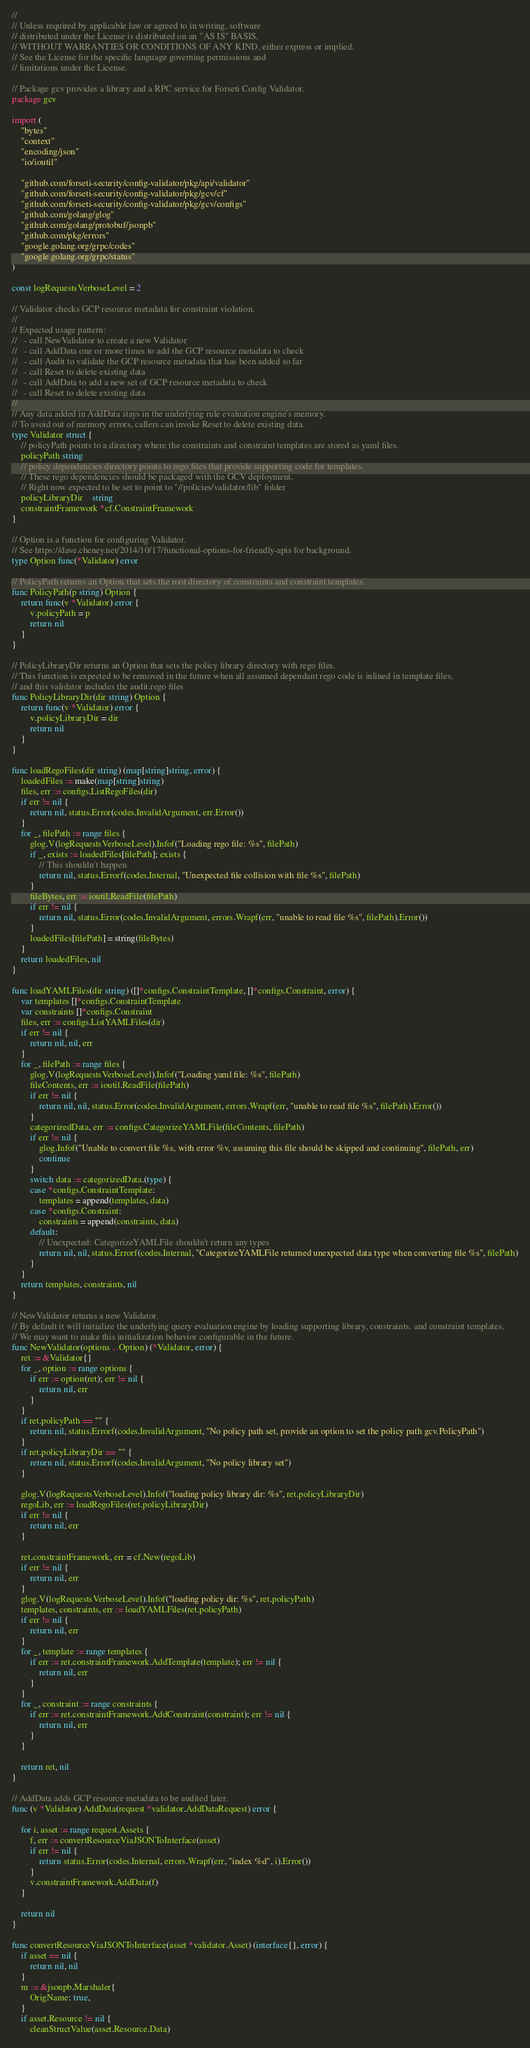<code> <loc_0><loc_0><loc_500><loc_500><_Go_>//
// Unless required by applicable law or agreed to in writing, software
// distributed under the License is distributed on an "AS IS" BASIS,
// WITHOUT WARRANTIES OR CONDITIONS OF ANY KIND, either express or implied.
// See the License for the specific language governing permissions and
// limitations under the License.

// Package gcv provides a library and a RPC service for Forseti Config Validator.
package gcv

import (
	"bytes"
	"context"
	"encoding/json"
	"io/ioutil"

	"github.com/forseti-security/config-validator/pkg/api/validator"
	"github.com/forseti-security/config-validator/pkg/gcv/cf"
	"github.com/forseti-security/config-validator/pkg/gcv/configs"
	"github.com/golang/glog"
	"github.com/golang/protobuf/jsonpb"
	"github.com/pkg/errors"
	"google.golang.org/grpc/codes"
	"google.golang.org/grpc/status"
)

const logRequestsVerboseLevel = 2

// Validator checks GCP resource metadata for constraint violation.
//
// Expected usage pattern:
//   - call NewValidator to create a new Validator
//   - call AddData one or more times to add the GCP resource metadata to check
//   - call Audit to validate the GCP resource metadata that has been added so far
//   - call Reset to delete existing data
//   - call AddData to add a new set of GCP resource metadata to check
//   - call Reset to delete existing data
//
// Any data added in AddData stays in the underlying rule evaluation engine's memory.
// To avoid out of memory errors, callers can invoke Reset to delete existing data.
type Validator struct {
	// policyPath points to a directory where the constraints and constraint templates are stored as yaml files.
	policyPath string
	// policy dependencies directory points to rego files that provide supporting code for templates.
	// These rego dependencies should be packaged with the GCV deployment.
	// Right now expected to be set to point to "//policies/validator/lib" folder
	policyLibraryDir    string
	constraintFramework *cf.ConstraintFramework
}

// Option is a function for configuring Validator.
// See https://dave.cheney.net/2014/10/17/functional-options-for-friendly-apis for background.
type Option func(*Validator) error

// PolicyPath returns an Option that sets the root directory of constraints and constraint templates.
func PolicyPath(p string) Option {
	return func(v *Validator) error {
		v.policyPath = p
		return nil
	}
}

// PolicyLibraryDir returns an Option that sets the policy library directory with rego files.
// This function is expected to be removed in the future when all assumed dependant rego code is inlined in template files,
// and this validator includes the audit.rego files
func PolicyLibraryDir(dir string) Option {
	return func(v *Validator) error {
		v.policyLibraryDir = dir
		return nil
	}
}

func loadRegoFiles(dir string) (map[string]string, error) {
	loadedFiles := make(map[string]string)
	files, err := configs.ListRegoFiles(dir)
	if err != nil {
		return nil, status.Error(codes.InvalidArgument, err.Error())
	}
	for _, filePath := range files {
		glog.V(logRequestsVerboseLevel).Infof("Loading rego file: %s", filePath)
		if _, exists := loadedFiles[filePath]; exists {
			// This shouldn't happen
			return nil, status.Errorf(codes.Internal, "Unexpected file collision with file %s", filePath)
		}
		fileBytes, err := ioutil.ReadFile(filePath)
		if err != nil {
			return nil, status.Error(codes.InvalidArgument, errors.Wrapf(err, "unable to read file %s", filePath).Error())
		}
		loadedFiles[filePath] = string(fileBytes)
	}
	return loadedFiles, nil
}

func loadYAMLFiles(dir string) ([]*configs.ConstraintTemplate, []*configs.Constraint, error) {
	var templates []*configs.ConstraintTemplate
	var constraints []*configs.Constraint
	files, err := configs.ListYAMLFiles(dir)
	if err != nil {
		return nil, nil, err
	}
	for _, filePath := range files {
		glog.V(logRequestsVerboseLevel).Infof("Loading yaml file: %s", filePath)
		fileContents, err := ioutil.ReadFile(filePath)
		if err != nil {
			return nil, nil, status.Error(codes.InvalidArgument, errors.Wrapf(err, "unable to read file %s", filePath).Error())
		}
		categorizedData, err := configs.CategorizeYAMLFile(fileContents, filePath)
		if err != nil {
			glog.Infof("Unable to convert file %s, with error %v, assuming this file should be skipped and continuing", filePath, err)
			continue
		}
		switch data := categorizedData.(type) {
		case *configs.ConstraintTemplate:
			templates = append(templates, data)
		case *configs.Constraint:
			constraints = append(constraints, data)
		default:
			// Unexpected: CategorizeYAMLFile shouldn't return any types
			return nil, nil, status.Errorf(codes.Internal, "CategorizeYAMLFile returned unexpected data type when converting file %s", filePath)
		}
	}
	return templates, constraints, nil
}

// NewValidator returns a new Validator.
// By default it will initialize the underlying query evaluation engine by loading supporting library, constraints, and constraint templates.
// We may want to make this initialization behavior configurable in the future.
func NewValidator(options ...Option) (*Validator, error) {
	ret := &Validator{}
	for _, option := range options {
		if err := option(ret); err != nil {
			return nil, err
		}
	}
	if ret.policyPath == "" {
		return nil, status.Errorf(codes.InvalidArgument, "No policy path set, provide an option to set the policy path gcv.PolicyPath")
	}
	if ret.policyLibraryDir == "" {
		return nil, status.Errorf(codes.InvalidArgument, "No policy library set")
	}

	glog.V(logRequestsVerboseLevel).Infof("loading policy library dir: %s", ret.policyLibraryDir)
	regoLib, err := loadRegoFiles(ret.policyLibraryDir)
	if err != nil {
		return nil, err
	}

	ret.constraintFramework, err = cf.New(regoLib)
	if err != nil {
		return nil, err
	}
	glog.V(logRequestsVerboseLevel).Infof("loading policy dir: %s", ret.policyPath)
	templates, constraints, err := loadYAMLFiles(ret.policyPath)
	if err != nil {
		return nil, err
	}
	for _, template := range templates {
		if err := ret.constraintFramework.AddTemplate(template); err != nil {
			return nil, err
		}
	}
	for _, constraint := range constraints {
		if err := ret.constraintFramework.AddConstraint(constraint); err != nil {
			return nil, err
		}
	}

	return ret, nil
}

// AddData adds GCP resource metadata to be audited later.
func (v *Validator) AddData(request *validator.AddDataRequest) error {

	for i, asset := range request.Assets {
		f, err := convertResourceViaJSONToInterface(asset)
		if err != nil {
			return status.Error(codes.Internal, errors.Wrapf(err, "index %d", i).Error())
		}
		v.constraintFramework.AddData(f)
	}

	return nil
}

func convertResourceViaJSONToInterface(asset *validator.Asset) (interface{}, error) {
	if asset == nil {
		return nil, nil
	}
	m := &jsonpb.Marshaler{
		OrigName: true,
	}
	if asset.Resource != nil {
		cleanStructValue(asset.Resource.Data)</code> 